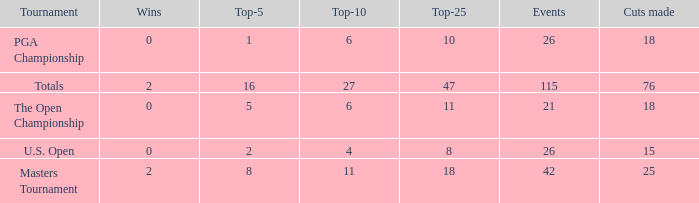What are the largest cuts made when the events are less than 21? None. Could you parse the entire table as a dict? {'header': ['Tournament', 'Wins', 'Top-5', 'Top-10', 'Top-25', 'Events', 'Cuts made'], 'rows': [['PGA Championship', '0', '1', '6', '10', '26', '18'], ['Totals', '2', '16', '27', '47', '115', '76'], ['The Open Championship', '0', '5', '6', '11', '21', '18'], ['U.S. Open', '0', '2', '4', '8', '26', '15'], ['Masters Tournament', '2', '8', '11', '18', '42', '25']]} 